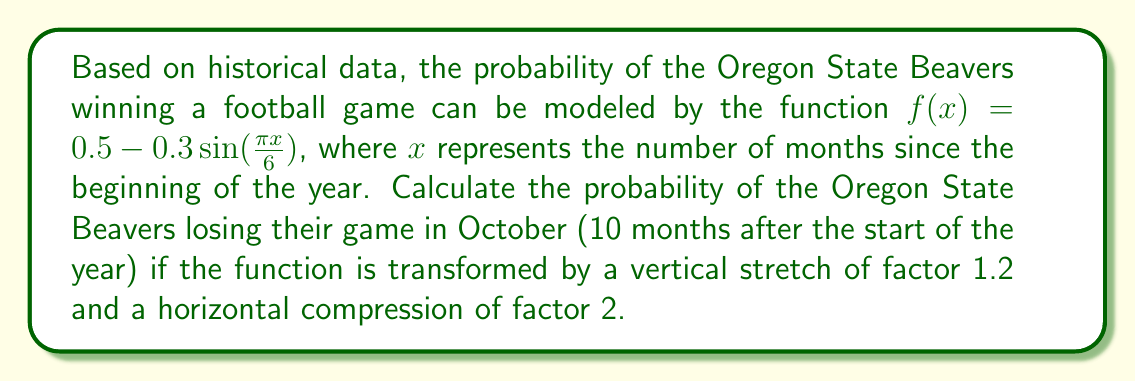Can you answer this question? Let's approach this step-by-step:

1) First, we need to apply the transformations to the original function $f(x) = 0.5 - 0.3\sin(\frac{\pi x}{6})$:
   
   - Vertical stretch of factor 1.2: $1.2f(x) = 1.2(0.5 - 0.3\sin(\frac{\pi x}{6}))$
   - Horizontal compression of factor 2: $1.2f(2x) = 1.2(0.5 - 0.3\sin(\frac{\pi (2x)}{6}))$

2) The transformed function is:
   $$g(x) = 1.2(0.5 - 0.3\sin(\frac{\pi x}{3}))$$

3) We need to find $g(10)$ since October is 10 months after the start of the year:
   $$g(10) = 1.2(0.5 - 0.3\sin(\frac{10\pi}{3}))$$

4) Calculate $\sin(\frac{10\pi}{3})$:
   $$\sin(\frac{10\pi}{3}) = \sin(\frac{\pi}{3}) = \frac{\sqrt{3}}{2}$$

5) Now we can substitute this value:
   $$g(10) = 1.2(0.5 - 0.3(\frac{\sqrt{3}}{2}))$$

6) Simplify:
   $$g(10) = 1.2(0.5 - 0.3(\frac{\sqrt{3}}{2})) = 0.6 - 0.36(\frac{\sqrt{3}}{2}) \approx 0.2882$$

7) This gives us the probability of the Beavers winning. To find the probability of losing, we subtract from 1:
   $$1 - 0.2882 = 0.7118$$

Therefore, the probability of the Oregon State Beavers losing their game in October under these conditions is approximately 0.7118 or 71.18%.
Answer: The probability of the Oregon State Beavers losing their game in October under the given conditions is approximately 0.7118 or 71.18%. 